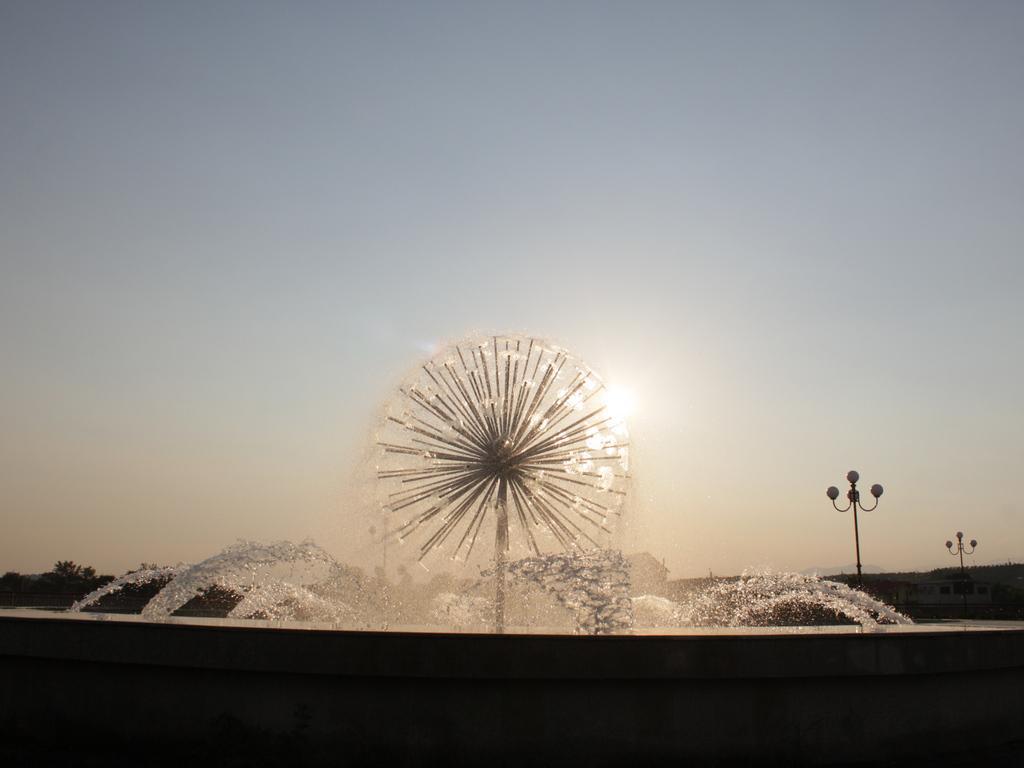In one or two sentences, can you explain what this image depicts? In the picture I can see street lights, the water and some other objects. In the background I can see trees, the sky and the sun. 